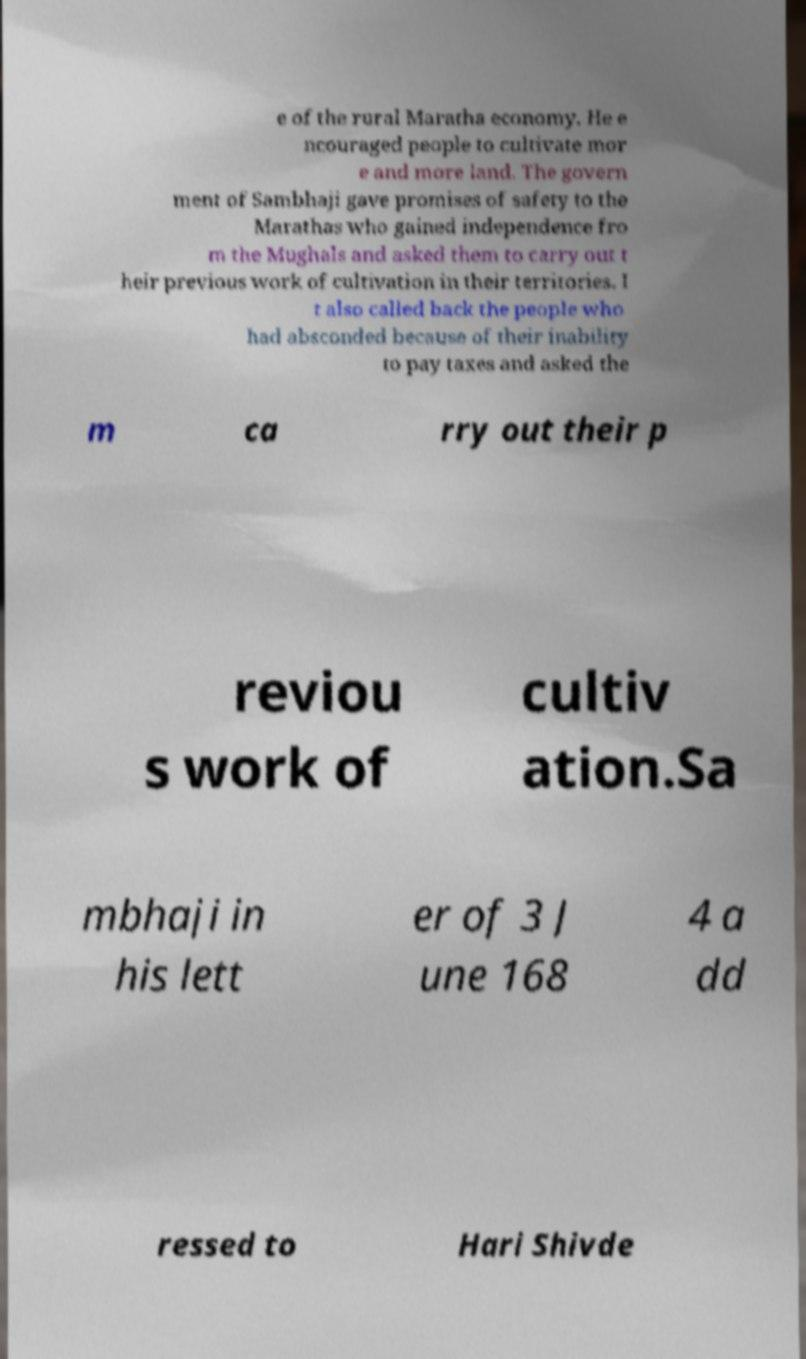Could you assist in decoding the text presented in this image and type it out clearly? e of the rural Maratha economy. He e ncouraged people to cultivate mor e and more land. The govern ment of Sambhaji gave promises of safety to the Marathas who gained independence fro m the Mughals and asked them to carry out t heir previous work of cultivation in their territories. I t also called back the people who had absconded because of their inability to pay taxes and asked the m ca rry out their p reviou s work of cultiv ation.Sa mbhaji in his lett er of 3 J une 168 4 a dd ressed to Hari Shivde 